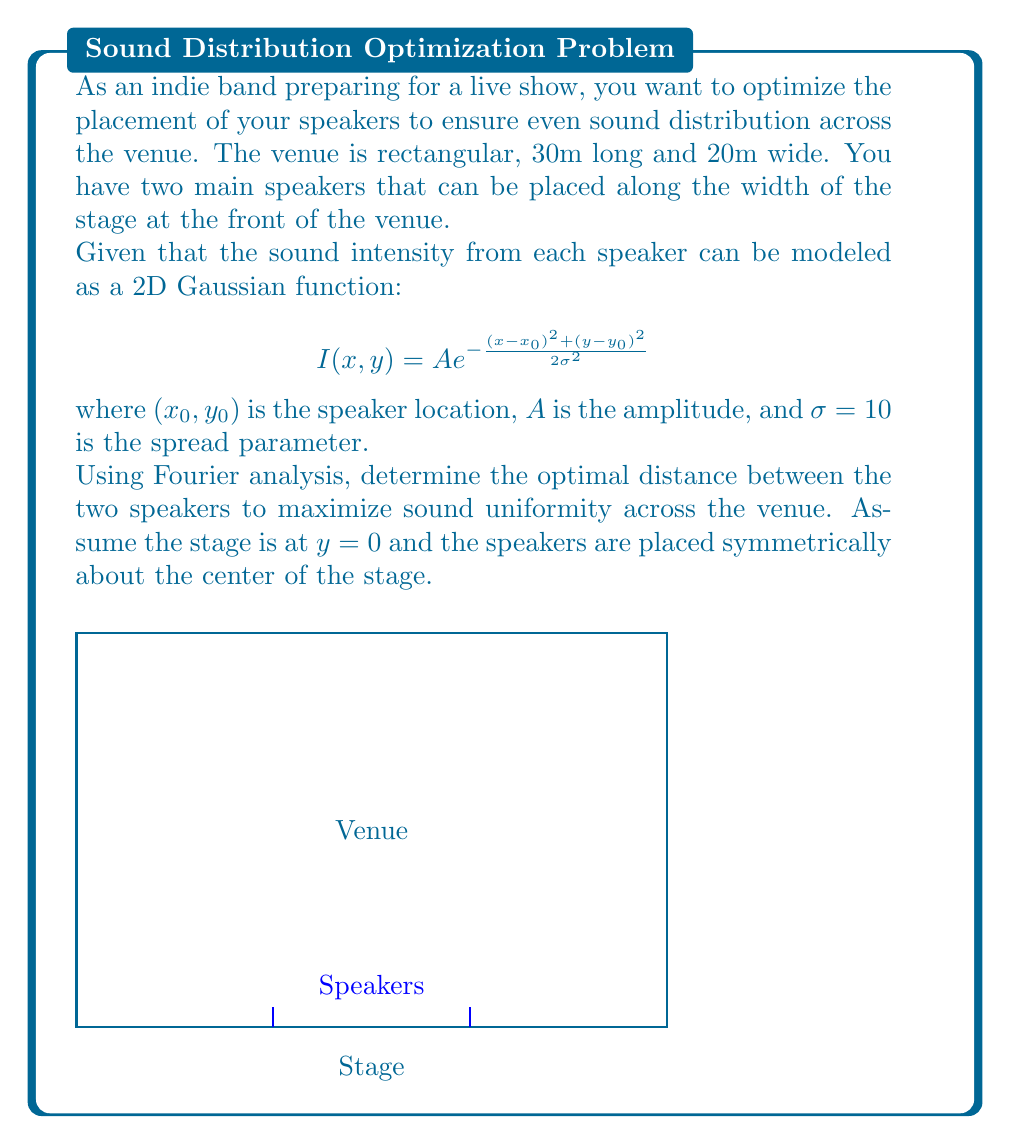Could you help me with this problem? To solve this problem, we'll use Fourier analysis to determine the optimal speaker placement:

1) First, we need to express the total sound intensity as the sum of two Gaussian functions:

   $$I(x,y) = A e^{-\frac{(x-x_1)^2 + y^2}{2\sigma^2}} + A e^{-\frac{(x-x_2)^2 + y^2}{2\sigma^2}}$$

   where $x_1 = 15 - d/2$ and $x_2 = 15 + d/2$, with $d$ being the distance between speakers.

2) To analyze uniformity, we'll take the 2D Fourier transform of this function:

   $$F(k_x, k_y) = \int_{-\infty}^{\infty}\int_{-\infty}^{\infty} I(x,y) e^{-i(k_x x + k_y y)} dx dy$$

3) The Fourier transform of a Gaussian is another Gaussian. After some calculation, we get:

   $$F(k_x, k_y) = 2\pi A \sigma^2 e^{-\frac{\sigma^2(k_x^2 + k_y^2)}{2}} (e^{-ik_x x_1} + e^{-ik_x x_2})$$

4) The magnitude of this Fourier transform is:

   $$|F(k_x, k_y)| = 4\pi A \sigma^2 e^{-\frac{\sigma^2(k_x^2 + k_y^2)}{2}} \cos(\frac{k_x d}{2})$$

5) For uniform sound, we want to minimize variations in the Fourier magnitude. This occurs when the cosine term is as flat as possible for low frequencies.

6) The first zero of the cosine term occurs when $k_x d/2 = \pi/2$. For optimal uniformity, we want this to occur at the highest frequency of interest, which is related to the venue size. Let's say $k_x = 2\pi/L$ where $L = 30m$ is the venue length.

7) Solving for $d$:

   $$\frac{2\pi}{L} \cdot \frac{d}{2} = \frac{\pi}{2}$$
   $$d = \frac{L}{2} = 15m$$

Therefore, the optimal distance between speakers is 15m, or half the length of the venue.
Answer: 15m 